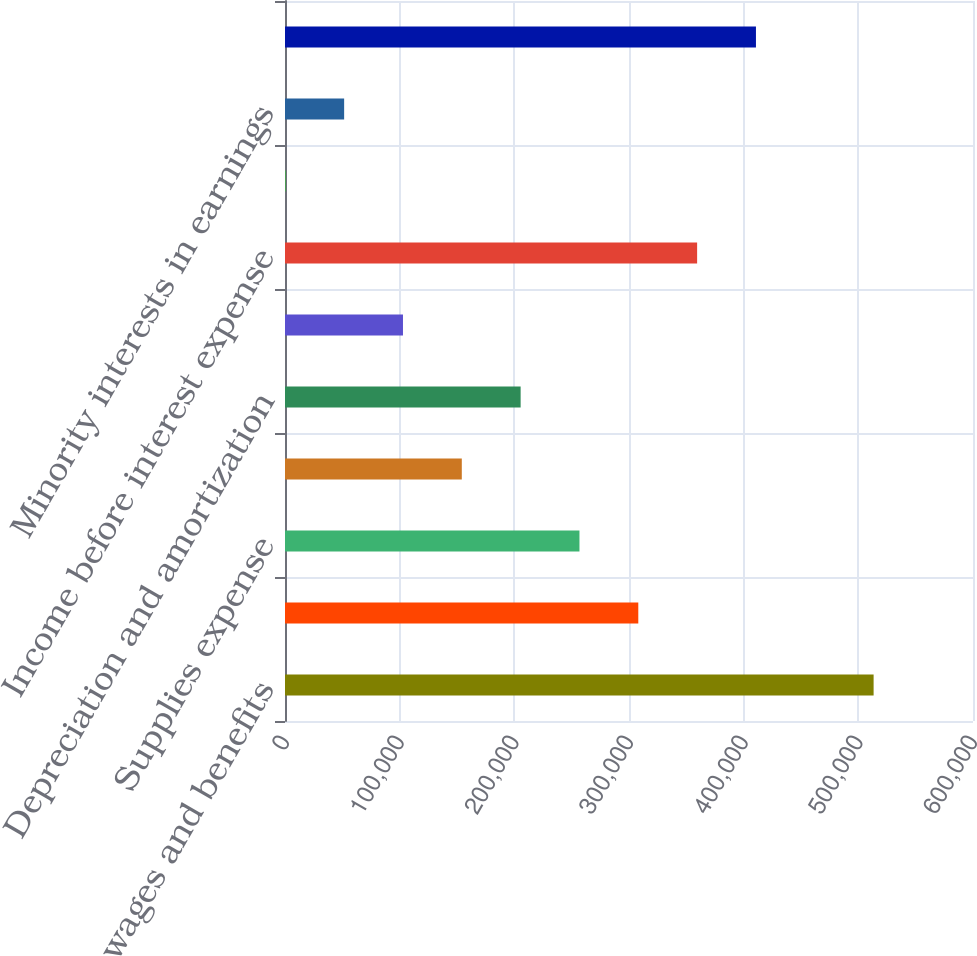Convert chart. <chart><loc_0><loc_0><loc_500><loc_500><bar_chart><fcel>Salaries wages and benefits<fcel>Other operating expenses<fcel>Supplies expense<fcel>Provision for doubtful<fcel>Depreciation and amortization<fcel>Lease and rental expense<fcel>Income before interest expense<fcel>Interest expense net<fcel>Minority interests in earnings<fcel>Income before income taxes<nl><fcel>513325<fcel>308105<fcel>256800<fcel>154189<fcel>205494<fcel>102884<fcel>359410<fcel>274<fcel>51579.1<fcel>410715<nl></chart> 